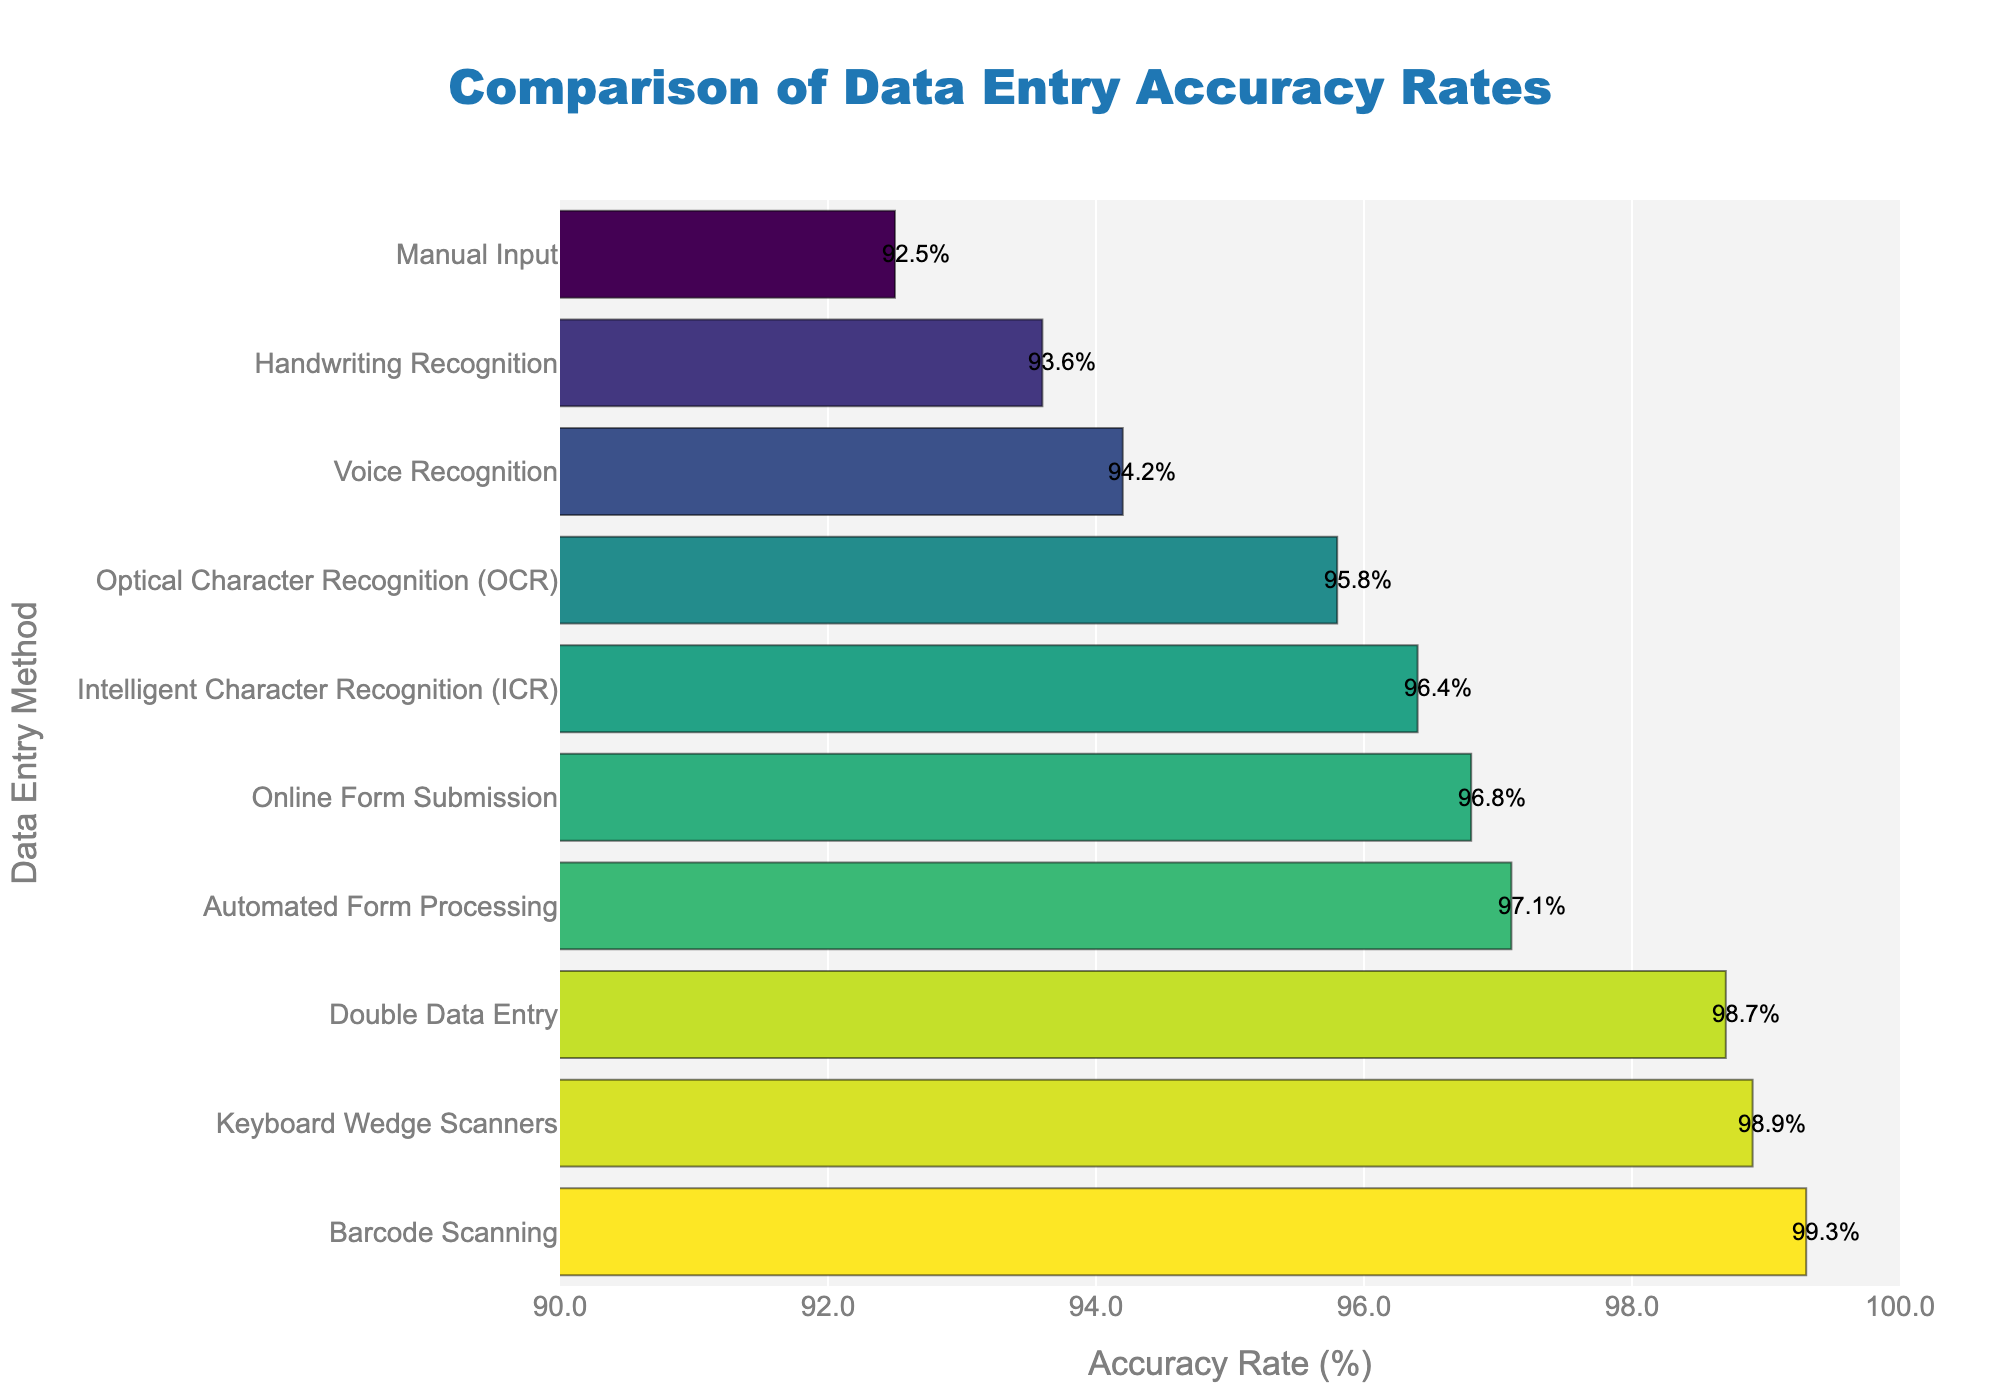Which data entry method has the highest accuracy rate? The highest bar in the chart represents the data entry method with the highest accuracy rate. Barcode Scanning has the highest bar, indicating it has the highest accuracy rate.
Answer: Barcode Scanning Which data entry methods have accuracy rates above 97%? Identify the bars with accuracy rates above 97%. Barcode Scanning, Double Data Entry, Keyboard Wedge Scanners, Automated Form Processing, and Online Form Submission have accuracy rates above 97%.
Answer: Barcode Scanning, Double Data Entry, Keyboard Wedge Scanners, Automated Form Processing, Online Form Submission What is the difference in accuracy rate between Barcode Scanning and Manual Input? Locate the bars for Barcode Scanning and Manual Input, then subtract the accuracy rate of Manual Input from Barcode Scanning. Barcode Scanning has 99.3% and Manual Input has 92.5%. The difference is 99.3% - 92.5% = 6.8%.
Answer: 6.8% What is the average accuracy rate of the automated systems listed (OCR, Voice Recognition, Automated Form Processing, ICR, and Online Form Submission)? Identify the accuracy rates of OCR, Voice Recognition, Automated Form Processing, ICR, and Online Form Submission. Sum these values and divide by the number of methods. (95.8% + 94.2% + 97.1% + 96.4% + 96.8%) / 5 = 96.06%.
Answer: 96.06% Which data entry method has the lowest accuracy rate that is still above 95%? Identify all methods with accuracy rates above 95%. The lowest accuracy rate among those is for OCR with 95.8%.
Answer: Optical Character Recognition (OCR) How many data entry methods have accuracy rates greater than 96%? Count the number of bars that have accuracy rates greater than 96%. Barcode Scanning, Double Data Entry, Automated Form Processing, ICR, and Online Form Submission meet this criterion.
Answer: 5 What is the range of accuracy rates for all data entry methods? Find the highest and lowest accuracy rates. The highest is Barcode Scanning with 99.3%, and the lowest is Manual Input with 92.5%. The range is 99.3% - 92.5% = 6.8%.
Answer: 6.8% Which data entry methods fall within the accuracy range of 94%-97%? Identify the bars with accuracy rates between 94% and 97%. Voice Recognition, Handwriting Recognition, Intelligent Character Recognition (ICR), and Online Form Submission fall within this range.
Answer: Voice Recognition, Handwriting Recognition, Intelligent Character Recognition (ICR), Online Form Submission 